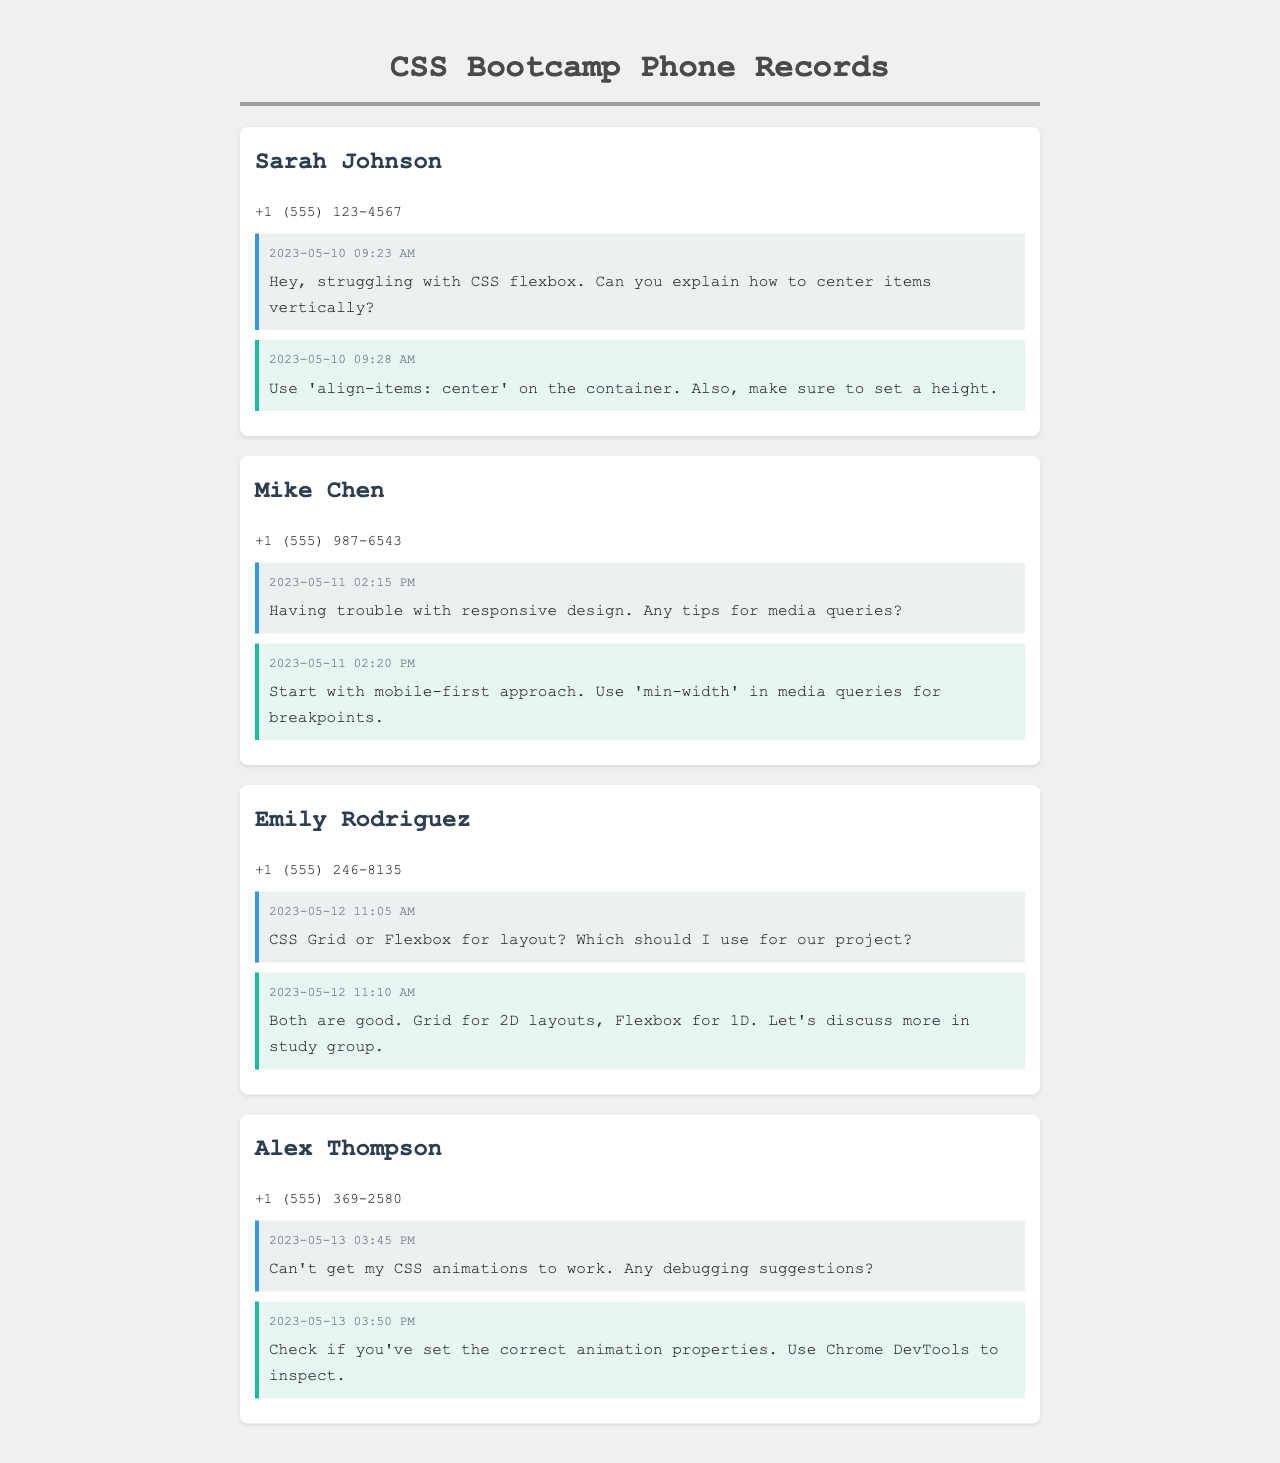What date did Sarah Johnson ask about centering items vertically in CSS? The date is found in the message header of Sarah's conversation where she mentions struggling with CSS flexbox.
Answer: 2023-05-10 What is Mike Chen's question regarding responsive design? Mike's question is included in his messages about media queries, specifically asking for tips.
Answer: Any tips for media queries? Which contact discussed CSS Grid or Flexbox? Emily Rodriguez asked about using CSS Grid or Flexbox for their project in the message content.
Answer: Emily Rodriguez What was Alex Thompson's issue related to CSS? Alex mentioned that he couldn’t get his CSS animations to work, which is found in his message content.
Answer: CSS animations What suggestion was given to Alex to debug his animations? The suggestion is outlined in the response to Alex regarding checking animation properties and using Chrome DevTools.
Answer: Check if you've set the correct animation properties Which member mentioned using a mobile-first approach? Mike Chen mentioned the mobile-first approach in his message about media queries.
Answer: Mike Chen What time was Sarah's first message sent? The time is noted in her message header stating when she reached out for help with flexbox.
Answer: 09:23 AM What was Emily's response regarding layout choices? Emily suggested using Grid for 2D layouts and Flexbox for 1D layouts in her message.
Answer: Grid for 2D layouts, Flexbox for 1D When did Mike Chen send his messages? The date is mentioned in the messages that he sent regarding responsive design.
Answer: 2023-05-11 